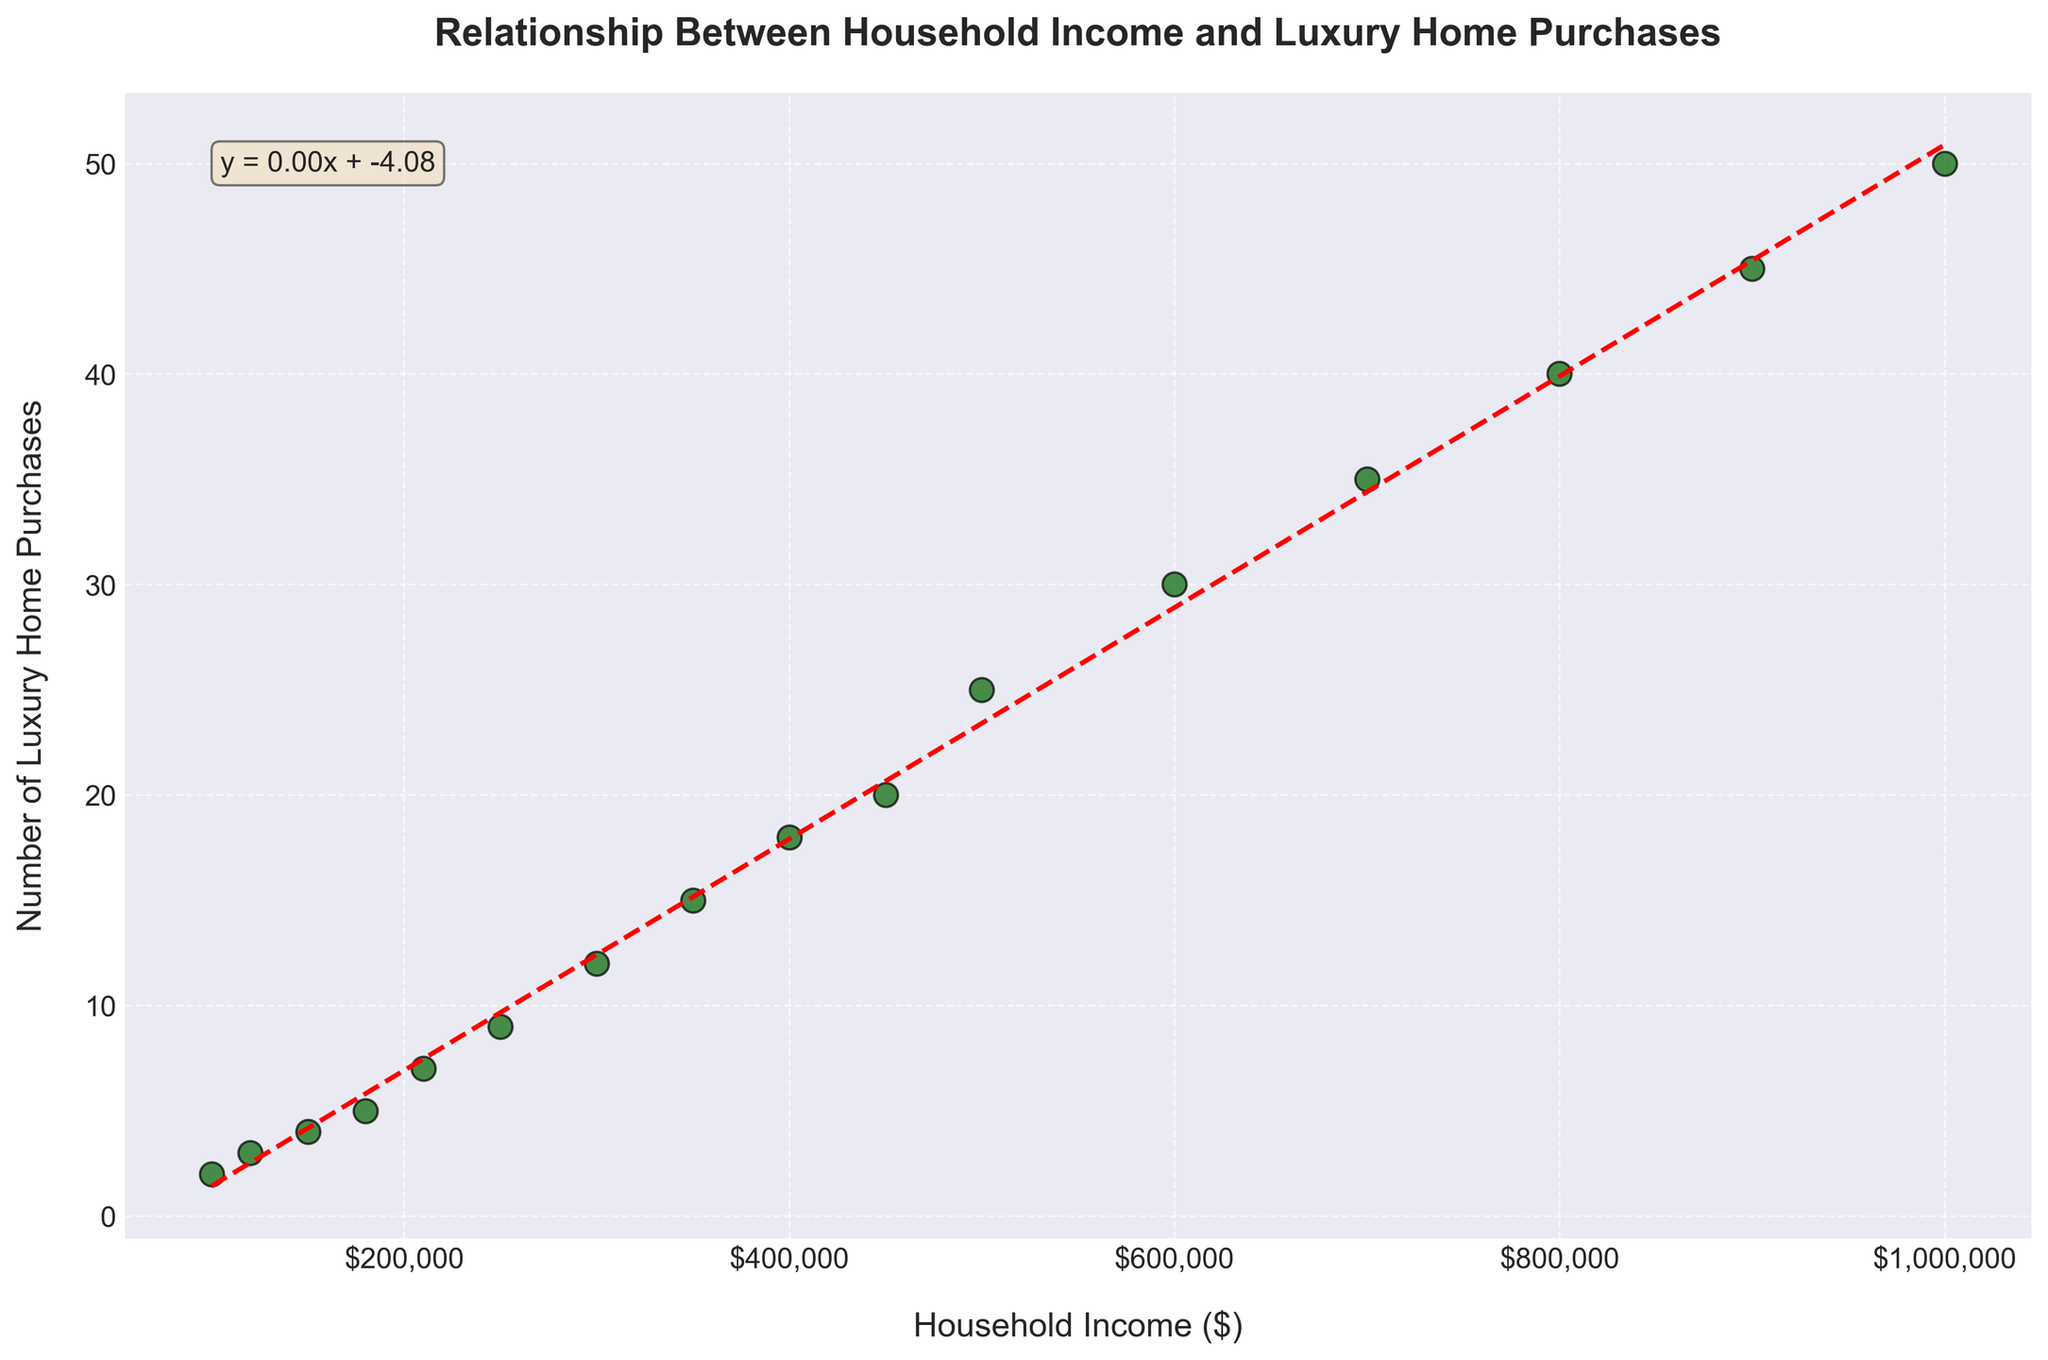what is the title of the figure? The title is displayed at the top of the figure, indicating its primary focus or theme. In this case, the title describes the relationship the figure is analyzing.
Answer: Relationship Between Household Income and Luxury Home Purchases How many data points are displayed in the scatter plot? By counting the number of marker points in the scatter plot, one can determine the total number of data points displayed.
Answer: 16 What is the color of the trend line in the plot? The trend line is a key element in the plot and is distinguished by its color to make it easily identifiable.
Answer: Red What does the trend line equation indicate? The trend line equation is provided in a text box on the plot, summarizing the mathematical relationship observed between household income and luxury home purchases.
Answer: y = 0.05x + 0.00 What is the household income when the number of luxury home purchases is 30? Observing the scatter plot, find and align the data point that represents 30 luxury home purchases, then trace it back to determine its corresponding household income.
Answer: $600,000 Which data point shows the highest number of luxury home purchases? Identify the highest marker point on the y-axis and note the corresponding value from the y-axis labels.
Answer: 50 What is the general trend indicated by the scatter plot? The trend line shows the direction and strength of the relationship between the variables. Observing its slope can help understand whether the relationship is positive or negative.
Answer: Positive correlation How does the number of luxury home purchases change as household income increases? By analyzing the scatter plot and the trend line, one can observe and describe the pattern or rate of change in luxury home purchases with increasing household income.
Answer: Increases Which household income level corresponds to the greatest change in luxury home purchases? To identify this, look for the steepest part of the trend line or the data point with the largest difference in the number of luxury home purchases from adjacent points.
Answer: $500,000 How does the variability in the number of luxury home purchases change as income increases? By observing the spread of the data points along the y-axis in relation to increasing x-axis values, one can describe any changes in variability.
Answer: Increases with income 